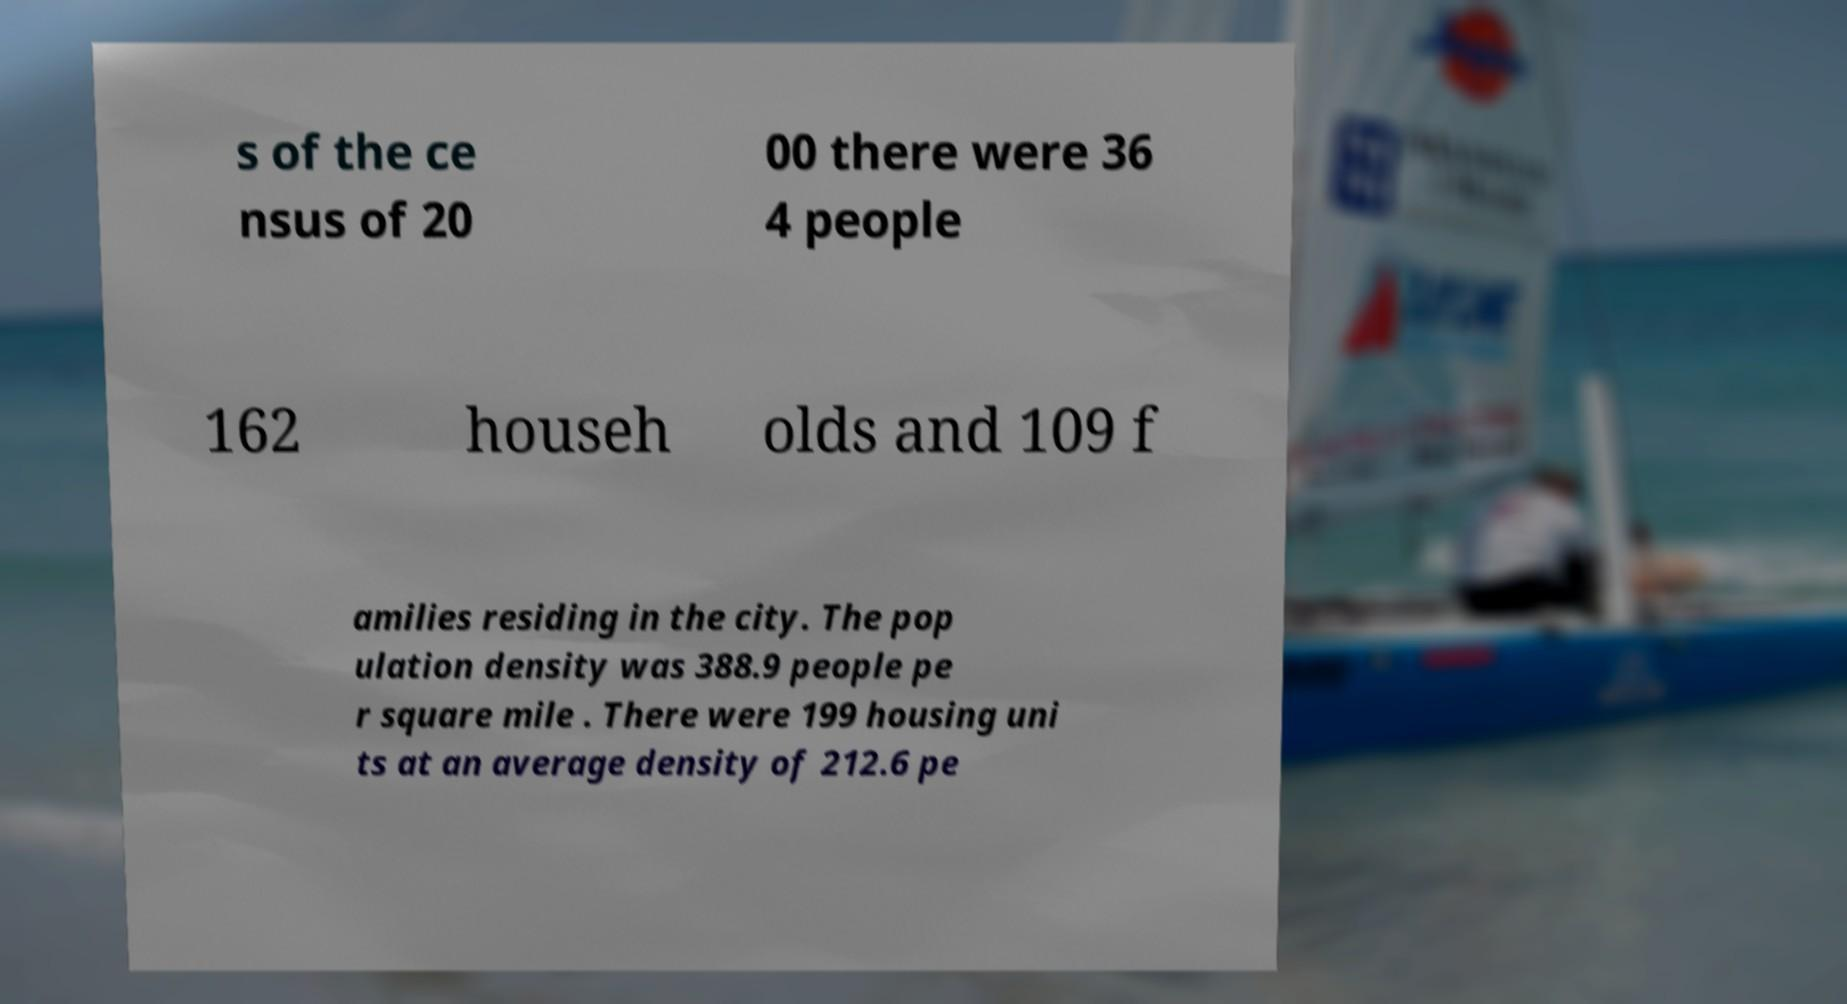Can you accurately transcribe the text from the provided image for me? s of the ce nsus of 20 00 there were 36 4 people 162 househ olds and 109 f amilies residing in the city. The pop ulation density was 388.9 people pe r square mile . There were 199 housing uni ts at an average density of 212.6 pe 